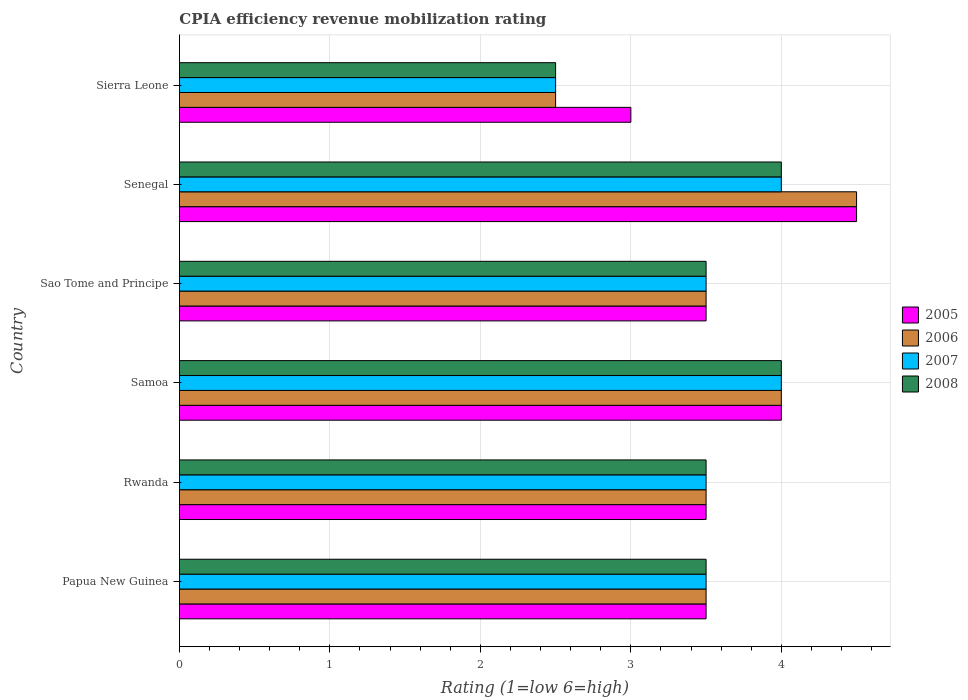Are the number of bars on each tick of the Y-axis equal?
Ensure brevity in your answer.  Yes. How many bars are there on the 6th tick from the top?
Your answer should be very brief. 4. How many bars are there on the 5th tick from the bottom?
Your answer should be very brief. 4. What is the label of the 1st group of bars from the top?
Your answer should be compact. Sierra Leone. In how many cases, is the number of bars for a given country not equal to the number of legend labels?
Provide a succinct answer. 0. What is the CPIA rating in 2007 in Senegal?
Offer a terse response. 4. Across all countries, what is the maximum CPIA rating in 2006?
Your answer should be compact. 4.5. Across all countries, what is the minimum CPIA rating in 2005?
Give a very brief answer. 3. In which country was the CPIA rating in 2005 maximum?
Make the answer very short. Senegal. In which country was the CPIA rating in 2008 minimum?
Your response must be concise. Sierra Leone. What is the average CPIA rating in 2005 per country?
Keep it short and to the point. 3.67. In how many countries, is the CPIA rating in 2007 greater than 0.2 ?
Provide a short and direct response. 6. Is the CPIA rating in 2008 in Senegal less than that in Sierra Leone?
Offer a very short reply. No. Is the difference between the CPIA rating in 2008 in Senegal and Sierra Leone greater than the difference between the CPIA rating in 2006 in Senegal and Sierra Leone?
Make the answer very short. No. What is the difference between the highest and the second highest CPIA rating in 2008?
Offer a very short reply. 0. In how many countries, is the CPIA rating in 2008 greater than the average CPIA rating in 2008 taken over all countries?
Your answer should be very brief. 2. Is the sum of the CPIA rating in 2006 in Rwanda and Sierra Leone greater than the maximum CPIA rating in 2007 across all countries?
Your response must be concise. Yes. Is it the case that in every country, the sum of the CPIA rating in 2008 and CPIA rating in 2006 is greater than the sum of CPIA rating in 2005 and CPIA rating in 2007?
Your response must be concise. No. What does the 2nd bar from the top in Sierra Leone represents?
Ensure brevity in your answer.  2007. What does the 4th bar from the bottom in Papua New Guinea represents?
Your response must be concise. 2008. How many bars are there?
Your answer should be compact. 24. Are all the bars in the graph horizontal?
Make the answer very short. Yes. How many countries are there in the graph?
Keep it short and to the point. 6. Does the graph contain any zero values?
Provide a succinct answer. No. Does the graph contain grids?
Your response must be concise. Yes. Where does the legend appear in the graph?
Provide a short and direct response. Center right. How many legend labels are there?
Give a very brief answer. 4. What is the title of the graph?
Keep it short and to the point. CPIA efficiency revenue mobilization rating. Does "2000" appear as one of the legend labels in the graph?
Keep it short and to the point. No. What is the label or title of the X-axis?
Keep it short and to the point. Rating (1=low 6=high). What is the Rating (1=low 6=high) in 2006 in Papua New Guinea?
Make the answer very short. 3.5. What is the Rating (1=low 6=high) of 2007 in Papua New Guinea?
Your answer should be very brief. 3.5. What is the Rating (1=low 6=high) in 2005 in Rwanda?
Offer a very short reply. 3.5. What is the Rating (1=low 6=high) of 2007 in Rwanda?
Provide a short and direct response. 3.5. What is the Rating (1=low 6=high) of 2006 in Sao Tome and Principe?
Ensure brevity in your answer.  3.5. What is the Rating (1=low 6=high) in 2007 in Sao Tome and Principe?
Your answer should be very brief. 3.5. What is the Rating (1=low 6=high) in 2005 in Senegal?
Your answer should be very brief. 4.5. What is the Rating (1=low 6=high) in 2006 in Senegal?
Your answer should be very brief. 4.5. What is the Rating (1=low 6=high) of 2008 in Senegal?
Your response must be concise. 4. What is the Rating (1=low 6=high) of 2006 in Sierra Leone?
Keep it short and to the point. 2.5. Across all countries, what is the maximum Rating (1=low 6=high) of 2005?
Your answer should be compact. 4.5. Across all countries, what is the minimum Rating (1=low 6=high) in 2005?
Keep it short and to the point. 3. Across all countries, what is the minimum Rating (1=low 6=high) in 2006?
Keep it short and to the point. 2.5. Across all countries, what is the minimum Rating (1=low 6=high) of 2007?
Offer a very short reply. 2.5. Across all countries, what is the minimum Rating (1=low 6=high) in 2008?
Your answer should be compact. 2.5. What is the total Rating (1=low 6=high) of 2005 in the graph?
Your answer should be compact. 22. What is the total Rating (1=low 6=high) in 2006 in the graph?
Provide a succinct answer. 21.5. What is the total Rating (1=low 6=high) in 2007 in the graph?
Offer a very short reply. 21. What is the total Rating (1=low 6=high) of 2008 in the graph?
Offer a very short reply. 21. What is the difference between the Rating (1=low 6=high) of 2007 in Papua New Guinea and that in Rwanda?
Your answer should be very brief. 0. What is the difference between the Rating (1=low 6=high) of 2005 in Papua New Guinea and that in Samoa?
Your answer should be compact. -0.5. What is the difference between the Rating (1=low 6=high) of 2006 in Papua New Guinea and that in Samoa?
Provide a short and direct response. -0.5. What is the difference between the Rating (1=low 6=high) in 2007 in Papua New Guinea and that in Samoa?
Keep it short and to the point. -0.5. What is the difference between the Rating (1=low 6=high) in 2005 in Papua New Guinea and that in Sao Tome and Principe?
Your answer should be very brief. 0. What is the difference between the Rating (1=low 6=high) of 2008 in Papua New Guinea and that in Sao Tome and Principe?
Keep it short and to the point. 0. What is the difference between the Rating (1=low 6=high) of 2006 in Papua New Guinea and that in Senegal?
Ensure brevity in your answer.  -1. What is the difference between the Rating (1=low 6=high) in 2008 in Papua New Guinea and that in Senegal?
Offer a terse response. -0.5. What is the difference between the Rating (1=low 6=high) of 2005 in Papua New Guinea and that in Sierra Leone?
Give a very brief answer. 0.5. What is the difference between the Rating (1=low 6=high) of 2007 in Rwanda and that in Samoa?
Keep it short and to the point. -0.5. What is the difference between the Rating (1=low 6=high) in 2005 in Rwanda and that in Sao Tome and Principe?
Provide a succinct answer. 0. What is the difference between the Rating (1=low 6=high) of 2007 in Rwanda and that in Sao Tome and Principe?
Provide a succinct answer. 0. What is the difference between the Rating (1=low 6=high) of 2008 in Rwanda and that in Sao Tome and Principe?
Keep it short and to the point. 0. What is the difference between the Rating (1=low 6=high) of 2005 in Rwanda and that in Senegal?
Offer a very short reply. -1. What is the difference between the Rating (1=low 6=high) in 2007 in Rwanda and that in Senegal?
Your answer should be very brief. -0.5. What is the difference between the Rating (1=low 6=high) of 2006 in Rwanda and that in Sierra Leone?
Keep it short and to the point. 1. What is the difference between the Rating (1=low 6=high) in 2008 in Rwanda and that in Sierra Leone?
Provide a succinct answer. 1. What is the difference between the Rating (1=low 6=high) of 2007 in Samoa and that in Sao Tome and Principe?
Offer a terse response. 0.5. What is the difference between the Rating (1=low 6=high) of 2005 in Samoa and that in Senegal?
Your answer should be very brief. -0.5. What is the difference between the Rating (1=low 6=high) in 2006 in Samoa and that in Senegal?
Ensure brevity in your answer.  -0.5. What is the difference between the Rating (1=low 6=high) in 2007 in Samoa and that in Senegal?
Keep it short and to the point. 0. What is the difference between the Rating (1=low 6=high) of 2005 in Samoa and that in Sierra Leone?
Keep it short and to the point. 1. What is the difference between the Rating (1=low 6=high) in 2008 in Samoa and that in Sierra Leone?
Give a very brief answer. 1.5. What is the difference between the Rating (1=low 6=high) in 2005 in Sao Tome and Principe and that in Senegal?
Ensure brevity in your answer.  -1. What is the difference between the Rating (1=low 6=high) of 2008 in Sao Tome and Principe and that in Senegal?
Offer a very short reply. -0.5. What is the difference between the Rating (1=low 6=high) of 2007 in Sao Tome and Principe and that in Sierra Leone?
Offer a terse response. 1. What is the difference between the Rating (1=low 6=high) of 2006 in Senegal and that in Sierra Leone?
Provide a short and direct response. 2. What is the difference between the Rating (1=low 6=high) in 2007 in Senegal and that in Sierra Leone?
Make the answer very short. 1.5. What is the difference between the Rating (1=low 6=high) in 2006 in Papua New Guinea and the Rating (1=low 6=high) in 2007 in Rwanda?
Provide a succinct answer. 0. What is the difference between the Rating (1=low 6=high) of 2007 in Papua New Guinea and the Rating (1=low 6=high) of 2008 in Rwanda?
Make the answer very short. 0. What is the difference between the Rating (1=low 6=high) of 2005 in Papua New Guinea and the Rating (1=low 6=high) of 2008 in Samoa?
Provide a short and direct response. -0.5. What is the difference between the Rating (1=low 6=high) in 2006 in Papua New Guinea and the Rating (1=low 6=high) in 2007 in Samoa?
Your answer should be very brief. -0.5. What is the difference between the Rating (1=low 6=high) of 2007 in Papua New Guinea and the Rating (1=low 6=high) of 2008 in Samoa?
Keep it short and to the point. -0.5. What is the difference between the Rating (1=low 6=high) of 2006 in Papua New Guinea and the Rating (1=low 6=high) of 2008 in Sao Tome and Principe?
Give a very brief answer. 0. What is the difference between the Rating (1=low 6=high) of 2005 in Papua New Guinea and the Rating (1=low 6=high) of 2006 in Senegal?
Give a very brief answer. -1. What is the difference between the Rating (1=low 6=high) in 2005 in Papua New Guinea and the Rating (1=low 6=high) in 2008 in Senegal?
Make the answer very short. -0.5. What is the difference between the Rating (1=low 6=high) of 2006 in Papua New Guinea and the Rating (1=low 6=high) of 2007 in Senegal?
Your answer should be compact. -0.5. What is the difference between the Rating (1=low 6=high) in 2006 in Papua New Guinea and the Rating (1=low 6=high) in 2008 in Senegal?
Offer a very short reply. -0.5. What is the difference between the Rating (1=low 6=high) in 2005 in Papua New Guinea and the Rating (1=low 6=high) in 2006 in Sierra Leone?
Your answer should be compact. 1. What is the difference between the Rating (1=low 6=high) in 2006 in Papua New Guinea and the Rating (1=low 6=high) in 2007 in Sierra Leone?
Provide a short and direct response. 1. What is the difference between the Rating (1=low 6=high) in 2006 in Papua New Guinea and the Rating (1=low 6=high) in 2008 in Sierra Leone?
Give a very brief answer. 1. What is the difference between the Rating (1=low 6=high) in 2007 in Papua New Guinea and the Rating (1=low 6=high) in 2008 in Sierra Leone?
Your response must be concise. 1. What is the difference between the Rating (1=low 6=high) in 2005 in Rwanda and the Rating (1=low 6=high) in 2006 in Samoa?
Make the answer very short. -0.5. What is the difference between the Rating (1=low 6=high) of 2005 in Rwanda and the Rating (1=low 6=high) of 2007 in Samoa?
Ensure brevity in your answer.  -0.5. What is the difference between the Rating (1=low 6=high) of 2006 in Rwanda and the Rating (1=low 6=high) of 2008 in Samoa?
Provide a short and direct response. -0.5. What is the difference between the Rating (1=low 6=high) in 2005 in Rwanda and the Rating (1=low 6=high) in 2007 in Sao Tome and Principe?
Offer a terse response. 0. What is the difference between the Rating (1=low 6=high) in 2005 in Rwanda and the Rating (1=low 6=high) in 2008 in Sao Tome and Principe?
Offer a terse response. 0. What is the difference between the Rating (1=low 6=high) in 2006 in Rwanda and the Rating (1=low 6=high) in 2007 in Sao Tome and Principe?
Keep it short and to the point. 0. What is the difference between the Rating (1=low 6=high) in 2006 in Rwanda and the Rating (1=low 6=high) in 2008 in Sao Tome and Principe?
Provide a succinct answer. 0. What is the difference between the Rating (1=low 6=high) in 2007 in Rwanda and the Rating (1=low 6=high) in 2008 in Sao Tome and Principe?
Offer a very short reply. 0. What is the difference between the Rating (1=low 6=high) in 2005 in Rwanda and the Rating (1=low 6=high) in 2006 in Senegal?
Provide a succinct answer. -1. What is the difference between the Rating (1=low 6=high) in 2006 in Rwanda and the Rating (1=low 6=high) in 2007 in Senegal?
Offer a very short reply. -0.5. What is the difference between the Rating (1=low 6=high) of 2007 in Rwanda and the Rating (1=low 6=high) of 2008 in Senegal?
Make the answer very short. -0.5. What is the difference between the Rating (1=low 6=high) in 2005 in Rwanda and the Rating (1=low 6=high) in 2007 in Sierra Leone?
Make the answer very short. 1. What is the difference between the Rating (1=low 6=high) of 2006 in Rwanda and the Rating (1=low 6=high) of 2008 in Sierra Leone?
Ensure brevity in your answer.  1. What is the difference between the Rating (1=low 6=high) of 2007 in Samoa and the Rating (1=low 6=high) of 2008 in Sao Tome and Principe?
Make the answer very short. 0.5. What is the difference between the Rating (1=low 6=high) in 2005 in Samoa and the Rating (1=low 6=high) in 2007 in Senegal?
Your answer should be very brief. 0. What is the difference between the Rating (1=low 6=high) in 2005 in Samoa and the Rating (1=low 6=high) in 2008 in Senegal?
Provide a short and direct response. 0. What is the difference between the Rating (1=low 6=high) of 2007 in Samoa and the Rating (1=low 6=high) of 2008 in Senegal?
Make the answer very short. 0. What is the difference between the Rating (1=low 6=high) in 2006 in Sao Tome and Principe and the Rating (1=low 6=high) in 2007 in Senegal?
Provide a short and direct response. -0.5. What is the difference between the Rating (1=low 6=high) in 2006 in Sao Tome and Principe and the Rating (1=low 6=high) in 2008 in Senegal?
Give a very brief answer. -0.5. What is the difference between the Rating (1=low 6=high) of 2007 in Sao Tome and Principe and the Rating (1=low 6=high) of 2008 in Senegal?
Keep it short and to the point. -0.5. What is the difference between the Rating (1=low 6=high) in 2005 in Sao Tome and Principe and the Rating (1=low 6=high) in 2008 in Sierra Leone?
Offer a terse response. 1. What is the difference between the Rating (1=low 6=high) in 2006 in Sao Tome and Principe and the Rating (1=low 6=high) in 2007 in Sierra Leone?
Make the answer very short. 1. What is the difference between the Rating (1=low 6=high) of 2006 in Sao Tome and Principe and the Rating (1=low 6=high) of 2008 in Sierra Leone?
Make the answer very short. 1. What is the difference between the Rating (1=low 6=high) of 2005 in Senegal and the Rating (1=low 6=high) of 2007 in Sierra Leone?
Keep it short and to the point. 2. What is the difference between the Rating (1=low 6=high) in 2005 in Senegal and the Rating (1=low 6=high) in 2008 in Sierra Leone?
Your response must be concise. 2. What is the difference between the Rating (1=low 6=high) of 2007 in Senegal and the Rating (1=low 6=high) of 2008 in Sierra Leone?
Give a very brief answer. 1.5. What is the average Rating (1=low 6=high) in 2005 per country?
Your answer should be compact. 3.67. What is the average Rating (1=low 6=high) in 2006 per country?
Keep it short and to the point. 3.58. What is the average Rating (1=low 6=high) of 2007 per country?
Provide a succinct answer. 3.5. What is the average Rating (1=low 6=high) in 2008 per country?
Ensure brevity in your answer.  3.5. What is the difference between the Rating (1=low 6=high) of 2006 and Rating (1=low 6=high) of 2008 in Papua New Guinea?
Provide a succinct answer. 0. What is the difference between the Rating (1=low 6=high) of 2005 and Rating (1=low 6=high) of 2006 in Rwanda?
Offer a terse response. 0. What is the difference between the Rating (1=low 6=high) in 2006 and Rating (1=low 6=high) in 2008 in Rwanda?
Give a very brief answer. 0. What is the difference between the Rating (1=low 6=high) in 2006 and Rating (1=low 6=high) in 2007 in Samoa?
Your answer should be compact. 0. What is the difference between the Rating (1=low 6=high) of 2007 and Rating (1=low 6=high) of 2008 in Samoa?
Your response must be concise. 0. What is the difference between the Rating (1=low 6=high) in 2005 and Rating (1=low 6=high) in 2006 in Sao Tome and Principe?
Your answer should be very brief. 0. What is the difference between the Rating (1=low 6=high) of 2005 and Rating (1=low 6=high) of 2008 in Sao Tome and Principe?
Provide a short and direct response. 0. What is the difference between the Rating (1=low 6=high) of 2006 and Rating (1=low 6=high) of 2007 in Sao Tome and Principe?
Offer a very short reply. 0. What is the difference between the Rating (1=low 6=high) of 2006 and Rating (1=low 6=high) of 2008 in Sao Tome and Principe?
Provide a short and direct response. 0. What is the difference between the Rating (1=low 6=high) of 2007 and Rating (1=low 6=high) of 2008 in Sao Tome and Principe?
Provide a succinct answer. 0. What is the difference between the Rating (1=low 6=high) in 2005 and Rating (1=low 6=high) in 2007 in Senegal?
Provide a short and direct response. 0.5. What is the difference between the Rating (1=low 6=high) in 2005 and Rating (1=low 6=high) in 2008 in Senegal?
Give a very brief answer. 0.5. What is the difference between the Rating (1=low 6=high) of 2006 and Rating (1=low 6=high) of 2008 in Senegal?
Provide a succinct answer. 0.5. What is the difference between the Rating (1=low 6=high) of 2007 and Rating (1=low 6=high) of 2008 in Senegal?
Your answer should be compact. 0. What is the difference between the Rating (1=low 6=high) in 2005 and Rating (1=low 6=high) in 2006 in Sierra Leone?
Ensure brevity in your answer.  0.5. What is the difference between the Rating (1=low 6=high) in 2005 and Rating (1=low 6=high) in 2007 in Sierra Leone?
Your answer should be very brief. 0.5. What is the difference between the Rating (1=low 6=high) in 2006 and Rating (1=low 6=high) in 2008 in Sierra Leone?
Your answer should be very brief. 0. What is the ratio of the Rating (1=low 6=high) of 2005 in Papua New Guinea to that in Samoa?
Keep it short and to the point. 0.88. What is the ratio of the Rating (1=low 6=high) of 2006 in Papua New Guinea to that in Samoa?
Offer a very short reply. 0.88. What is the ratio of the Rating (1=low 6=high) in 2007 in Papua New Guinea to that in Samoa?
Your answer should be very brief. 0.88. What is the ratio of the Rating (1=low 6=high) in 2005 in Papua New Guinea to that in Sao Tome and Principe?
Provide a succinct answer. 1. What is the ratio of the Rating (1=low 6=high) in 2006 in Papua New Guinea to that in Sao Tome and Principe?
Provide a short and direct response. 1. What is the ratio of the Rating (1=low 6=high) of 2007 in Papua New Guinea to that in Sao Tome and Principe?
Offer a terse response. 1. What is the ratio of the Rating (1=low 6=high) in 2008 in Papua New Guinea to that in Sao Tome and Principe?
Give a very brief answer. 1. What is the ratio of the Rating (1=low 6=high) in 2005 in Papua New Guinea to that in Senegal?
Ensure brevity in your answer.  0.78. What is the ratio of the Rating (1=low 6=high) of 2006 in Papua New Guinea to that in Senegal?
Ensure brevity in your answer.  0.78. What is the ratio of the Rating (1=low 6=high) of 2007 in Papua New Guinea to that in Senegal?
Provide a short and direct response. 0.88. What is the ratio of the Rating (1=low 6=high) of 2005 in Papua New Guinea to that in Sierra Leone?
Offer a very short reply. 1.17. What is the ratio of the Rating (1=low 6=high) in 2007 in Papua New Guinea to that in Sierra Leone?
Provide a succinct answer. 1.4. What is the ratio of the Rating (1=low 6=high) of 2005 in Rwanda to that in Samoa?
Keep it short and to the point. 0.88. What is the ratio of the Rating (1=low 6=high) of 2006 in Rwanda to that in Samoa?
Make the answer very short. 0.88. What is the ratio of the Rating (1=low 6=high) of 2005 in Rwanda to that in Sao Tome and Principe?
Your answer should be very brief. 1. What is the ratio of the Rating (1=low 6=high) of 2006 in Rwanda to that in Senegal?
Your answer should be compact. 0.78. What is the ratio of the Rating (1=low 6=high) of 2008 in Rwanda to that in Senegal?
Make the answer very short. 0.88. What is the ratio of the Rating (1=low 6=high) of 2005 in Rwanda to that in Sierra Leone?
Give a very brief answer. 1.17. What is the ratio of the Rating (1=low 6=high) of 2006 in Rwanda to that in Sierra Leone?
Offer a terse response. 1.4. What is the ratio of the Rating (1=low 6=high) of 2007 in Rwanda to that in Sierra Leone?
Offer a terse response. 1.4. What is the ratio of the Rating (1=low 6=high) of 2005 in Samoa to that in Sao Tome and Principe?
Your answer should be compact. 1.14. What is the ratio of the Rating (1=low 6=high) in 2007 in Samoa to that in Sao Tome and Principe?
Give a very brief answer. 1.14. What is the ratio of the Rating (1=low 6=high) of 2005 in Samoa to that in Senegal?
Keep it short and to the point. 0.89. What is the ratio of the Rating (1=low 6=high) of 2006 in Samoa to that in Senegal?
Your response must be concise. 0.89. What is the ratio of the Rating (1=low 6=high) in 2008 in Samoa to that in Senegal?
Provide a succinct answer. 1. What is the ratio of the Rating (1=low 6=high) in 2005 in Samoa to that in Sierra Leone?
Offer a very short reply. 1.33. What is the ratio of the Rating (1=low 6=high) of 2005 in Sao Tome and Principe to that in Senegal?
Provide a succinct answer. 0.78. What is the ratio of the Rating (1=low 6=high) in 2006 in Sao Tome and Principe to that in Sierra Leone?
Offer a very short reply. 1.4. What is the ratio of the Rating (1=low 6=high) of 2007 in Sao Tome and Principe to that in Sierra Leone?
Offer a very short reply. 1.4. What is the ratio of the Rating (1=low 6=high) of 2008 in Sao Tome and Principe to that in Sierra Leone?
Offer a very short reply. 1.4. What is the ratio of the Rating (1=low 6=high) of 2006 in Senegal to that in Sierra Leone?
Give a very brief answer. 1.8. What is the ratio of the Rating (1=low 6=high) of 2007 in Senegal to that in Sierra Leone?
Provide a succinct answer. 1.6. What is the ratio of the Rating (1=low 6=high) in 2008 in Senegal to that in Sierra Leone?
Ensure brevity in your answer.  1.6. What is the difference between the highest and the second highest Rating (1=low 6=high) of 2007?
Keep it short and to the point. 0. What is the difference between the highest and the second highest Rating (1=low 6=high) in 2008?
Ensure brevity in your answer.  0. What is the difference between the highest and the lowest Rating (1=low 6=high) in 2005?
Keep it short and to the point. 1.5. What is the difference between the highest and the lowest Rating (1=low 6=high) of 2007?
Give a very brief answer. 1.5. What is the difference between the highest and the lowest Rating (1=low 6=high) in 2008?
Provide a succinct answer. 1.5. 